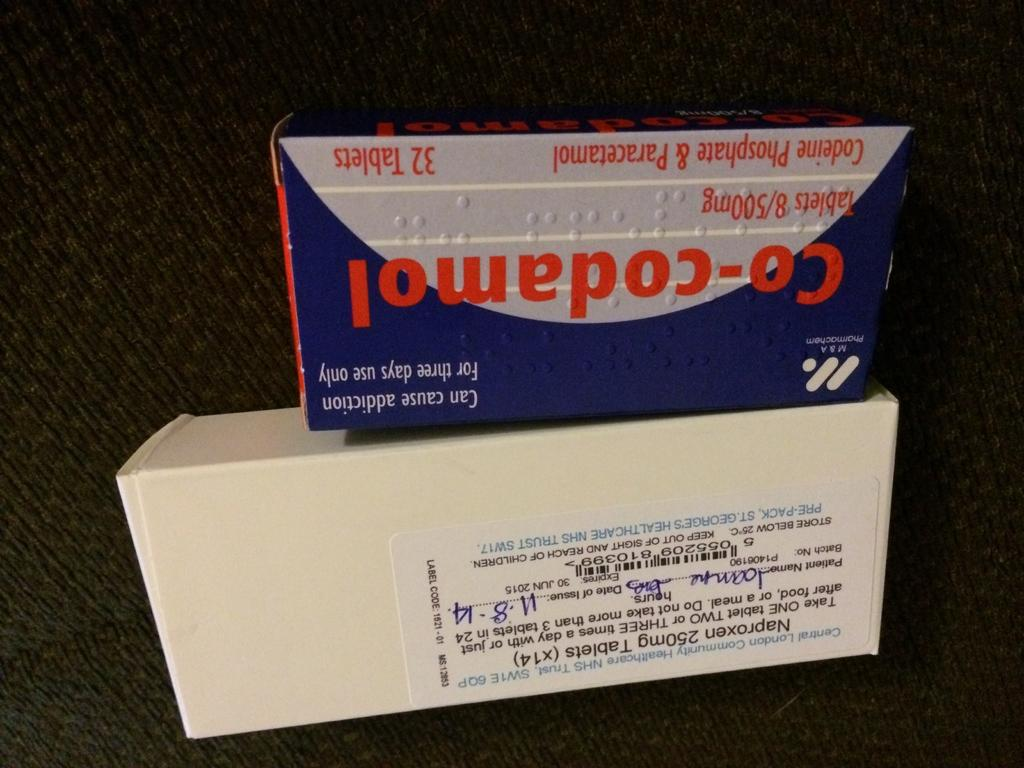<image>
Relay a brief, clear account of the picture shown. A box of Co-codamol tablets and a box of Naproxen 250mg Tablets. 